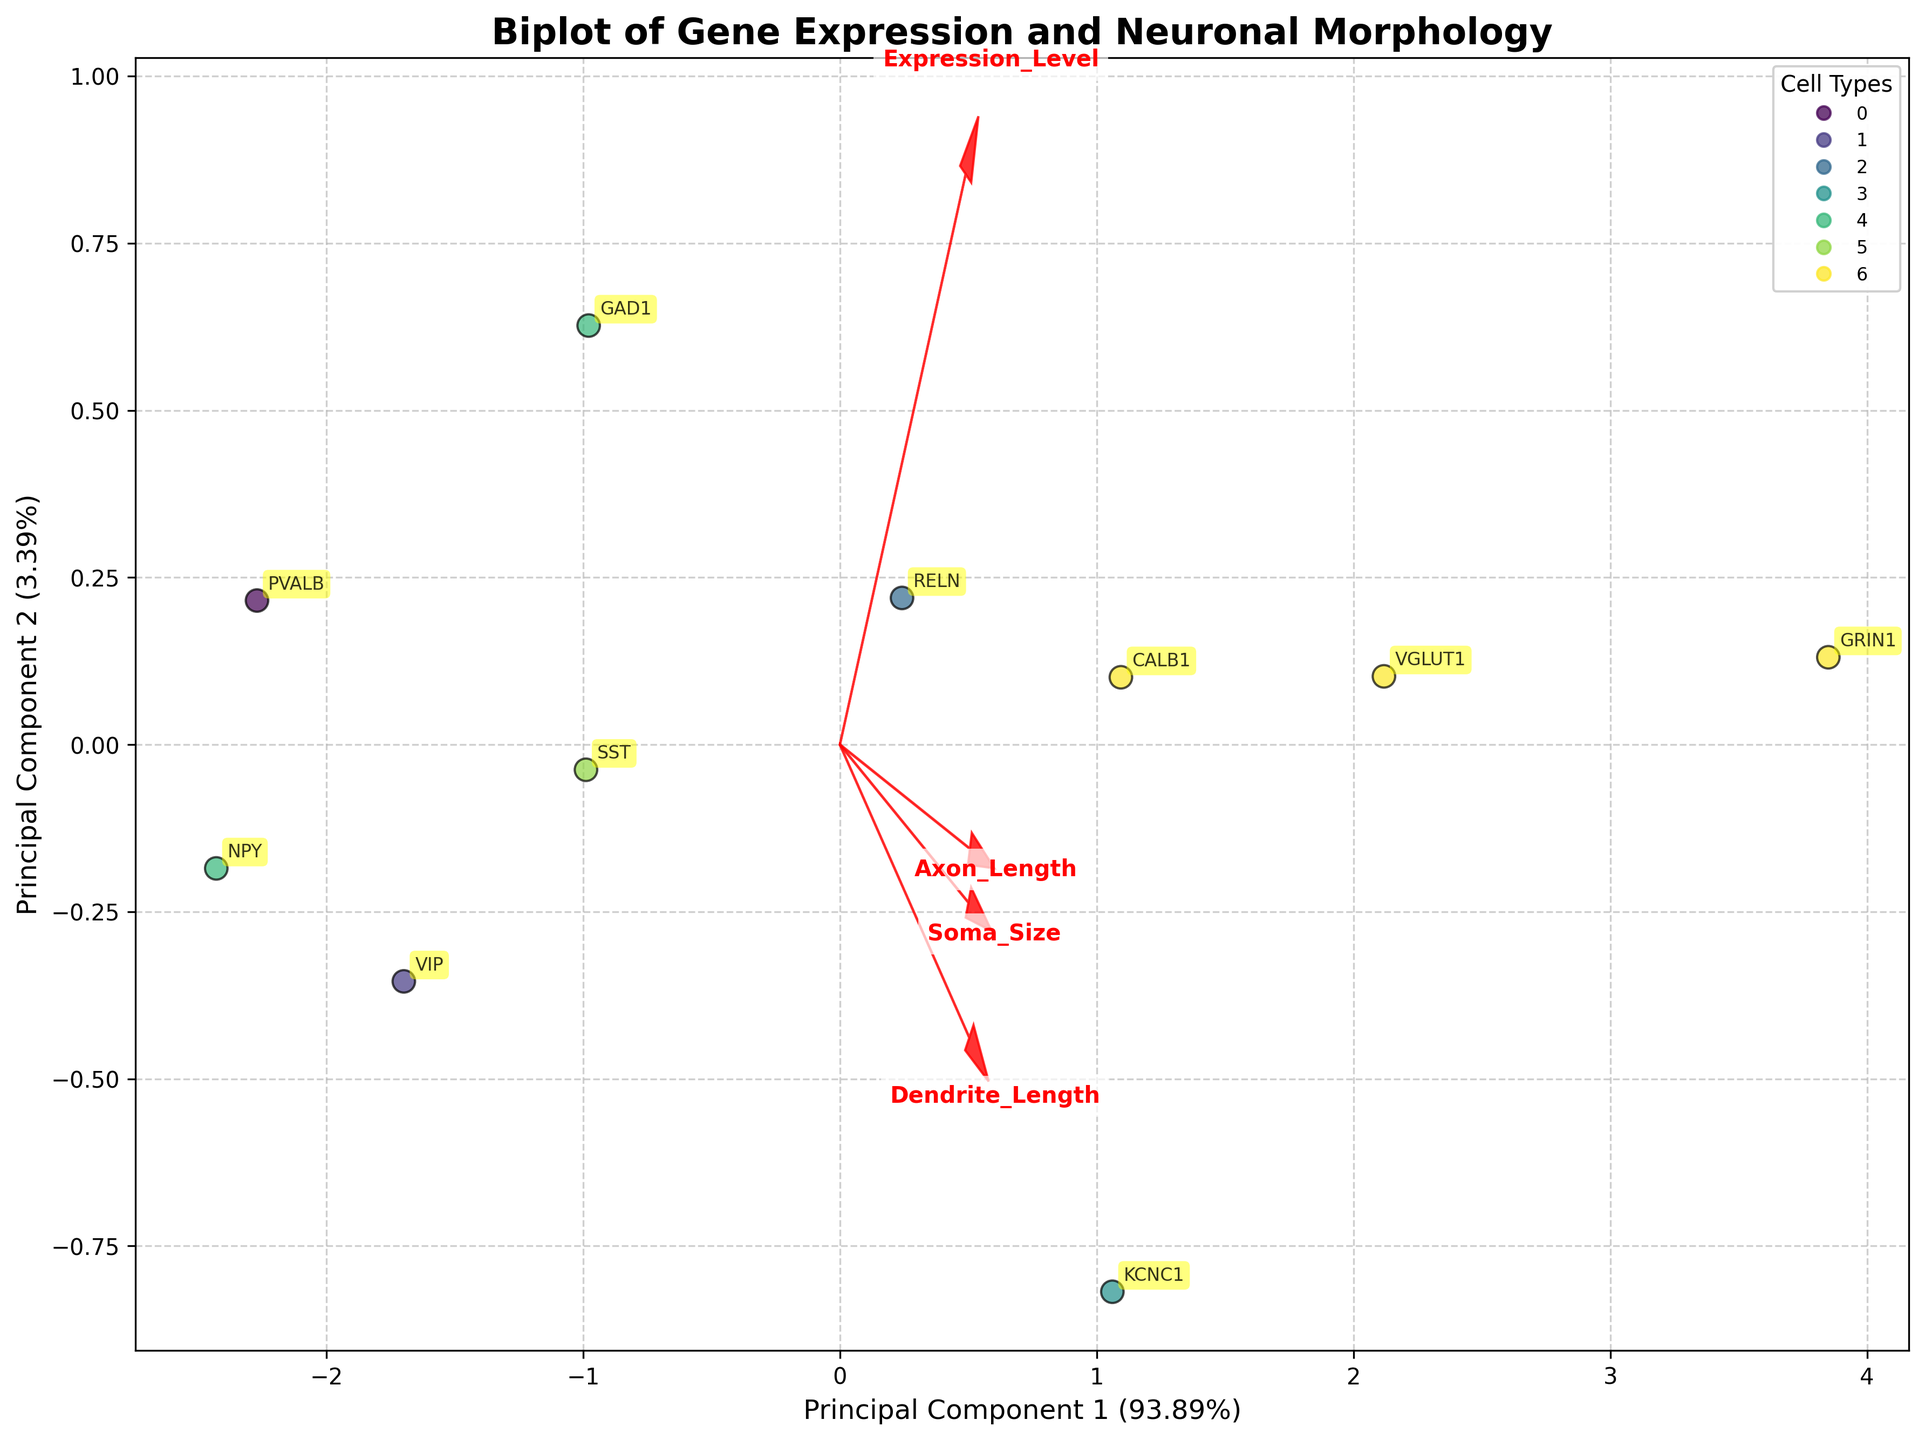What is the title of the plot? The title of the plot is displayed at the top, it is "Biplot of Gene Expression and Neuronal Morphology."
Answer: Biplot of Gene Expression and Neuronal Morphology How many different cell types are represented in the plot? We can identify the cell types based on the legend that assigns different colors to each cell type. The legend shows seven different labels.
Answer: Seven Which feature has the highest loading on Principal Component 1? The arrows and the feature names indicate the loadings on the principal components. The arrow with the longest projection on the Principal Component 1 axis corresponds to the feature with the highest loading. "Axon_Length" has the highest projection on PC1.
Answer: Axon_Length Which cell type has the highest value on Principal Component 2? Observing the y-axis (Principal Component 2), the point with the highest y-value belongs to the "Pyramidal_Neuron" cell type.
Answer: Pyramidal_Neuron Which gene is associated with the data point located at the highest value on Principal Component 2? The annotation for the data point with the highest y-value (on PC2) can be read directly from the plot. The gene associated with this point is "GRIN1."
Answer: GRIN1 Compare the overall positioning of Pyramidal Neurons and Interneurons on the biplot. Which principal component primarily distinguishes these two cell types? By examining the scatter plot, we see that "Pyramidal_Neuron" and "Interneuron" points occupy different regions. The separation along the Principal Component 1 axis is more significant than along Principal Component 2. Thus, PC1 primarily distinguishes these cell types.
Answer: Principal Component 1 How is "Dendrite Length" related to "Principal Component 1"? The arrow and its projection provide information about the relation of the feature with the principal components. The arrow for "Dendrite_Length" points towards negative values of Principal Component 1, indicating a negative correlation.
Answer: Negative correlation Which gene labels are closest to each other on the plot? Observing the close proximity of points allows us to identify that "NPY" and "PVALB" are the closest to each other on the biplot.
Answer: NPY and PVALB Which cell type is most likely to have the lowest "Soma_Size"? Observing the arrows and projections, especially the length and direction of the "Soma_Size" vector, and the positioning of points reveal that data points for "Interneuron" tend to be positioned in the negative direction along this vector, indicating lower "Soma_Size."
Answer: Interneuron 